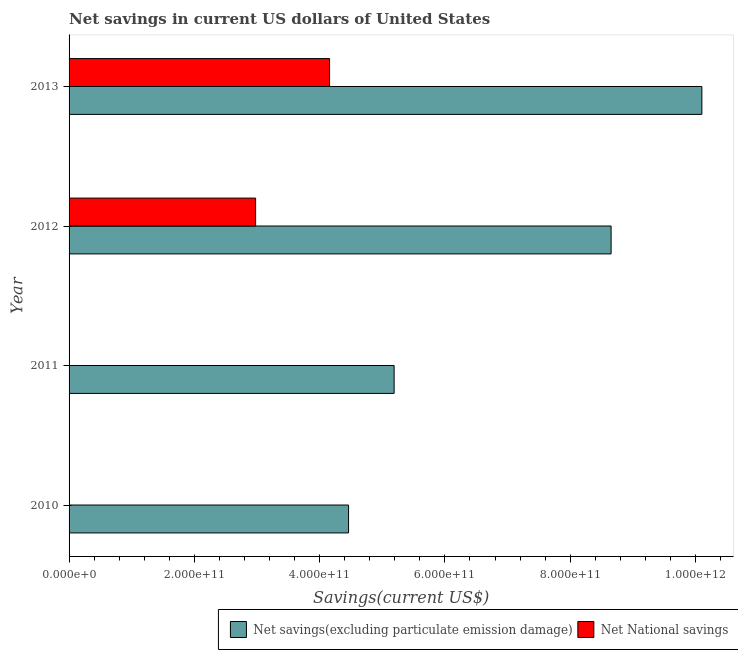How many different coloured bars are there?
Keep it short and to the point. 2. Are the number of bars on each tick of the Y-axis equal?
Keep it short and to the point. No. How many bars are there on the 4th tick from the bottom?
Offer a terse response. 2. In how many cases, is the number of bars for a given year not equal to the number of legend labels?
Your response must be concise. 2. Across all years, what is the maximum net national savings?
Provide a succinct answer. 4.16e+11. Across all years, what is the minimum net savings(excluding particulate emission damage)?
Keep it short and to the point. 4.46e+11. What is the total net savings(excluding particulate emission damage) in the graph?
Make the answer very short. 2.84e+12. What is the difference between the net savings(excluding particulate emission damage) in 2012 and that in 2013?
Your answer should be compact. -1.45e+11. What is the difference between the net savings(excluding particulate emission damage) in 2012 and the net national savings in 2011?
Offer a very short reply. 8.65e+11. What is the average net national savings per year?
Ensure brevity in your answer.  1.78e+11. In the year 2012, what is the difference between the net national savings and net savings(excluding particulate emission damage)?
Ensure brevity in your answer.  -5.68e+11. What is the ratio of the net savings(excluding particulate emission damage) in 2010 to that in 2011?
Provide a succinct answer. 0.86. Is the net savings(excluding particulate emission damage) in 2010 less than that in 2012?
Ensure brevity in your answer.  Yes. What is the difference between the highest and the second highest net savings(excluding particulate emission damage)?
Your answer should be compact. 1.45e+11. What is the difference between the highest and the lowest net national savings?
Your answer should be compact. 4.16e+11. In how many years, is the net savings(excluding particulate emission damage) greater than the average net savings(excluding particulate emission damage) taken over all years?
Provide a succinct answer. 2. Are all the bars in the graph horizontal?
Make the answer very short. Yes. How many years are there in the graph?
Keep it short and to the point. 4. What is the difference between two consecutive major ticks on the X-axis?
Your answer should be compact. 2.00e+11. Does the graph contain any zero values?
Your answer should be compact. Yes. What is the title of the graph?
Your response must be concise. Net savings in current US dollars of United States. Does "Net National savings" appear as one of the legend labels in the graph?
Keep it short and to the point. Yes. What is the label or title of the X-axis?
Ensure brevity in your answer.  Savings(current US$). What is the Savings(current US$) in Net savings(excluding particulate emission damage) in 2010?
Make the answer very short. 4.46e+11. What is the Savings(current US$) of Net savings(excluding particulate emission damage) in 2011?
Your answer should be very brief. 5.19e+11. What is the Savings(current US$) of Net National savings in 2011?
Provide a succinct answer. 0. What is the Savings(current US$) of Net savings(excluding particulate emission damage) in 2012?
Your answer should be compact. 8.65e+11. What is the Savings(current US$) of Net National savings in 2012?
Provide a succinct answer. 2.98e+11. What is the Savings(current US$) in Net savings(excluding particulate emission damage) in 2013?
Your response must be concise. 1.01e+12. What is the Savings(current US$) in Net National savings in 2013?
Your answer should be compact. 4.16e+11. Across all years, what is the maximum Savings(current US$) of Net savings(excluding particulate emission damage)?
Your response must be concise. 1.01e+12. Across all years, what is the maximum Savings(current US$) in Net National savings?
Your response must be concise. 4.16e+11. Across all years, what is the minimum Savings(current US$) of Net savings(excluding particulate emission damage)?
Give a very brief answer. 4.46e+11. Across all years, what is the minimum Savings(current US$) of Net National savings?
Your answer should be very brief. 0. What is the total Savings(current US$) of Net savings(excluding particulate emission damage) in the graph?
Your answer should be compact. 2.84e+12. What is the total Savings(current US$) of Net National savings in the graph?
Your answer should be very brief. 7.14e+11. What is the difference between the Savings(current US$) of Net savings(excluding particulate emission damage) in 2010 and that in 2011?
Your response must be concise. -7.27e+1. What is the difference between the Savings(current US$) in Net savings(excluding particulate emission damage) in 2010 and that in 2012?
Your response must be concise. -4.19e+11. What is the difference between the Savings(current US$) in Net savings(excluding particulate emission damage) in 2010 and that in 2013?
Offer a terse response. -5.64e+11. What is the difference between the Savings(current US$) of Net savings(excluding particulate emission damage) in 2011 and that in 2012?
Your answer should be very brief. -3.46e+11. What is the difference between the Savings(current US$) of Net savings(excluding particulate emission damage) in 2011 and that in 2013?
Your answer should be compact. -4.91e+11. What is the difference between the Savings(current US$) in Net savings(excluding particulate emission damage) in 2012 and that in 2013?
Keep it short and to the point. -1.45e+11. What is the difference between the Savings(current US$) of Net National savings in 2012 and that in 2013?
Ensure brevity in your answer.  -1.18e+11. What is the difference between the Savings(current US$) of Net savings(excluding particulate emission damage) in 2010 and the Savings(current US$) of Net National savings in 2012?
Ensure brevity in your answer.  1.48e+11. What is the difference between the Savings(current US$) of Net savings(excluding particulate emission damage) in 2010 and the Savings(current US$) of Net National savings in 2013?
Give a very brief answer. 3.03e+1. What is the difference between the Savings(current US$) in Net savings(excluding particulate emission damage) in 2011 and the Savings(current US$) in Net National savings in 2012?
Keep it short and to the point. 2.21e+11. What is the difference between the Savings(current US$) of Net savings(excluding particulate emission damage) in 2011 and the Savings(current US$) of Net National savings in 2013?
Your answer should be compact. 1.03e+11. What is the difference between the Savings(current US$) in Net savings(excluding particulate emission damage) in 2012 and the Savings(current US$) in Net National savings in 2013?
Give a very brief answer. 4.49e+11. What is the average Savings(current US$) of Net savings(excluding particulate emission damage) per year?
Provide a short and direct response. 7.10e+11. What is the average Savings(current US$) of Net National savings per year?
Your answer should be compact. 1.78e+11. In the year 2012, what is the difference between the Savings(current US$) of Net savings(excluding particulate emission damage) and Savings(current US$) of Net National savings?
Make the answer very short. 5.68e+11. In the year 2013, what is the difference between the Savings(current US$) in Net savings(excluding particulate emission damage) and Savings(current US$) in Net National savings?
Make the answer very short. 5.94e+11. What is the ratio of the Savings(current US$) of Net savings(excluding particulate emission damage) in 2010 to that in 2011?
Make the answer very short. 0.86. What is the ratio of the Savings(current US$) in Net savings(excluding particulate emission damage) in 2010 to that in 2012?
Offer a very short reply. 0.52. What is the ratio of the Savings(current US$) in Net savings(excluding particulate emission damage) in 2010 to that in 2013?
Keep it short and to the point. 0.44. What is the ratio of the Savings(current US$) in Net savings(excluding particulate emission damage) in 2011 to that in 2012?
Offer a very short reply. 0.6. What is the ratio of the Savings(current US$) in Net savings(excluding particulate emission damage) in 2011 to that in 2013?
Your answer should be compact. 0.51. What is the ratio of the Savings(current US$) of Net savings(excluding particulate emission damage) in 2012 to that in 2013?
Provide a succinct answer. 0.86. What is the ratio of the Savings(current US$) in Net National savings in 2012 to that in 2013?
Keep it short and to the point. 0.72. What is the difference between the highest and the second highest Savings(current US$) in Net savings(excluding particulate emission damage)?
Provide a succinct answer. 1.45e+11. What is the difference between the highest and the lowest Savings(current US$) of Net savings(excluding particulate emission damage)?
Provide a succinct answer. 5.64e+11. What is the difference between the highest and the lowest Savings(current US$) of Net National savings?
Give a very brief answer. 4.16e+11. 